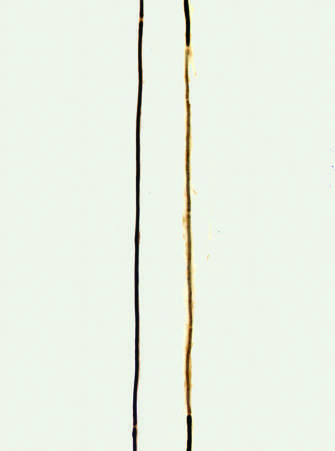what does the right axon, by contrast, show?
Answer the question using a single word or phrase. A segment surrounded by a series of thinly myelinated internodes of uneven length flanked on both ends by normal thicker myelin internodes 